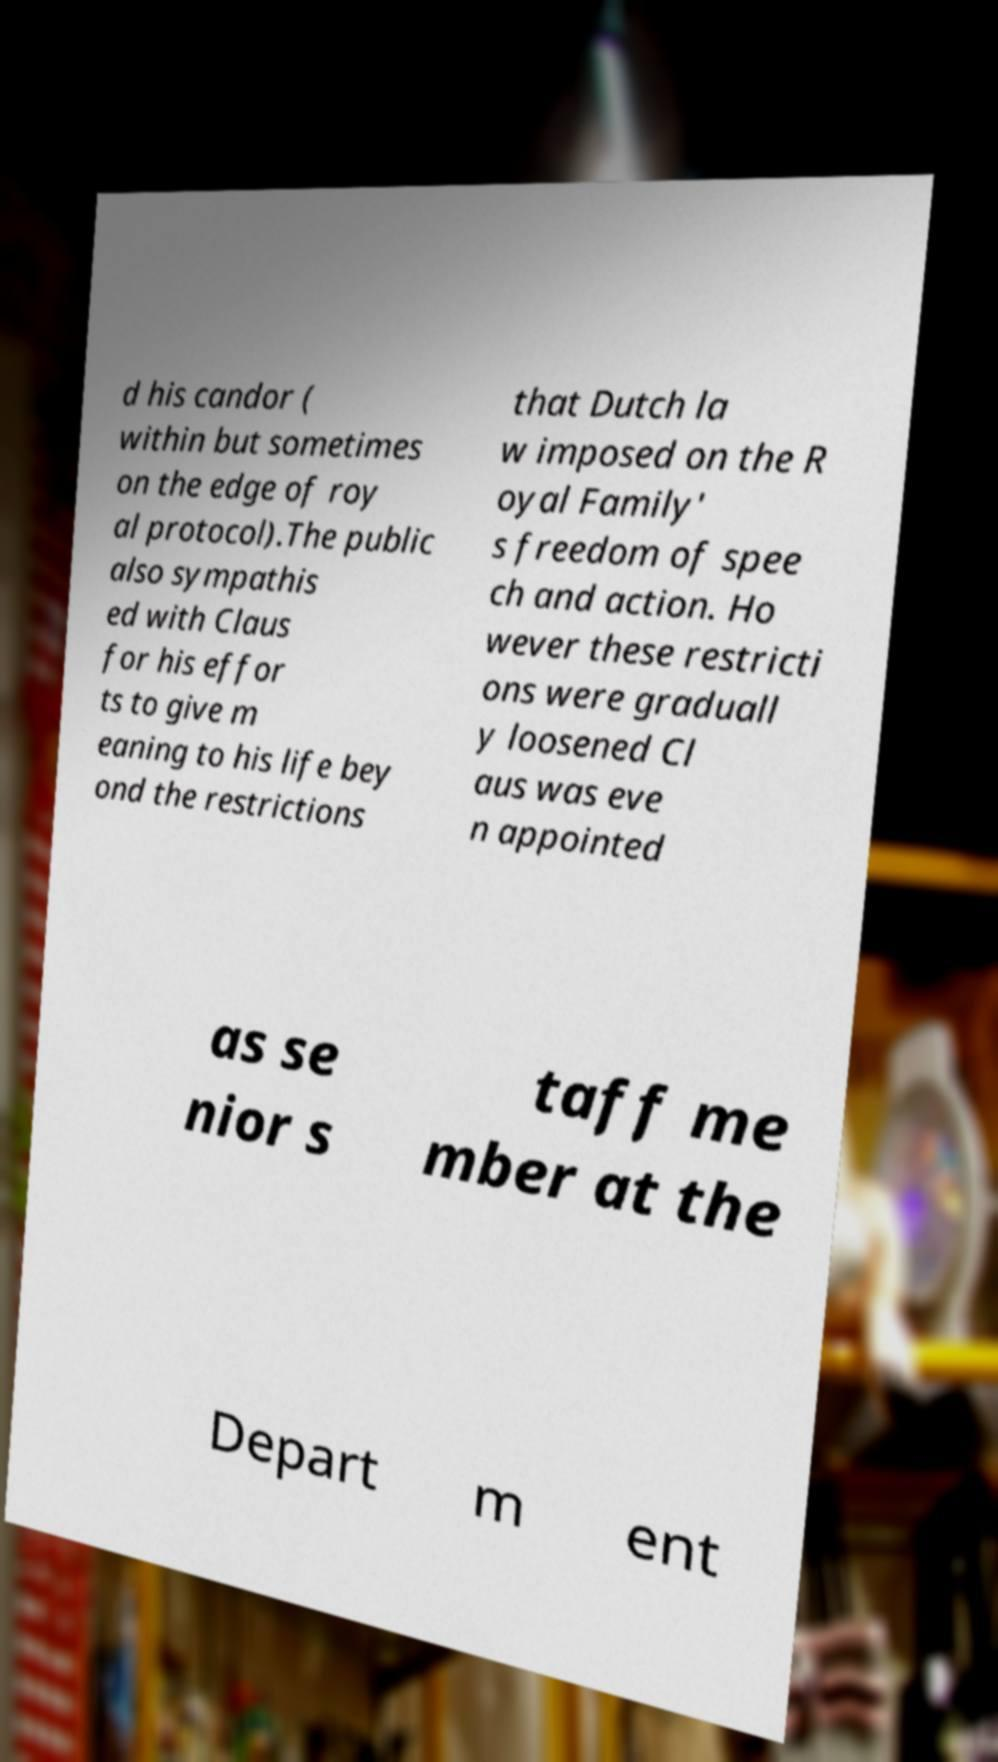Could you extract and type out the text from this image? d his candor ( within but sometimes on the edge of roy al protocol).The public also sympathis ed with Claus for his effor ts to give m eaning to his life bey ond the restrictions that Dutch la w imposed on the R oyal Family' s freedom of spee ch and action. Ho wever these restricti ons were graduall y loosened Cl aus was eve n appointed as se nior s taff me mber at the Depart m ent 